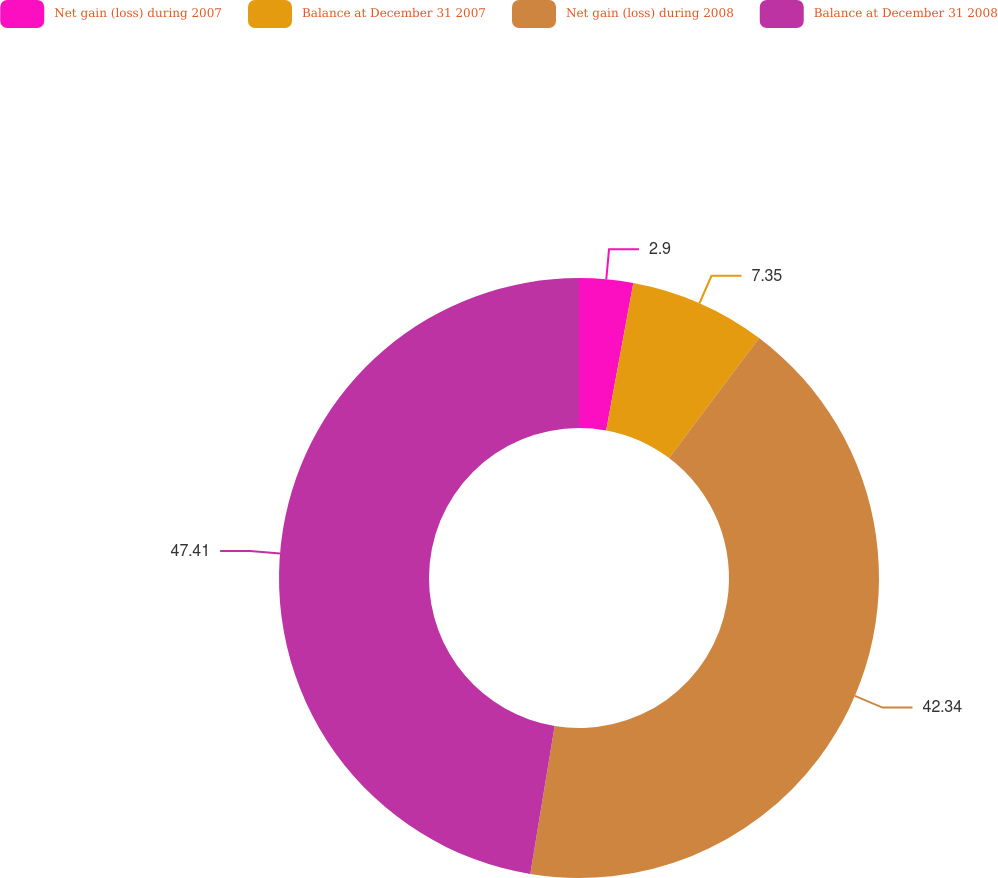Convert chart. <chart><loc_0><loc_0><loc_500><loc_500><pie_chart><fcel>Net gain (loss) during 2007<fcel>Balance at December 31 2007<fcel>Net gain (loss) during 2008<fcel>Balance at December 31 2008<nl><fcel>2.9%<fcel>7.35%<fcel>42.34%<fcel>47.4%<nl></chart> 